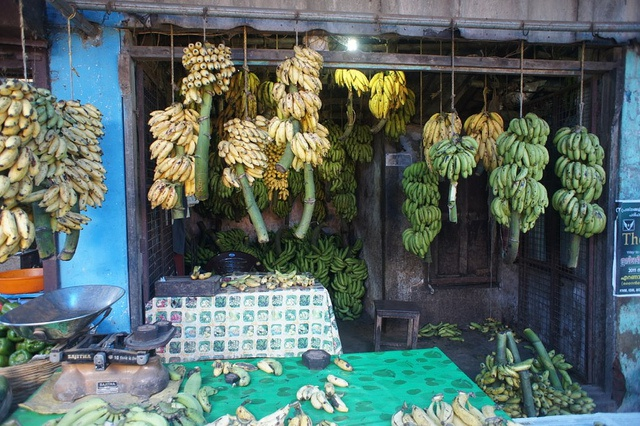Describe the objects in this image and their specific colors. I can see banana in black, gray, darkgreen, and darkgray tones, dining table in black, turquoise, darkgray, and beige tones, banana in black, tan, gray, darkgray, and olive tones, dining table in black, gray, white, and darkgray tones, and banana in black and tan tones in this image. 